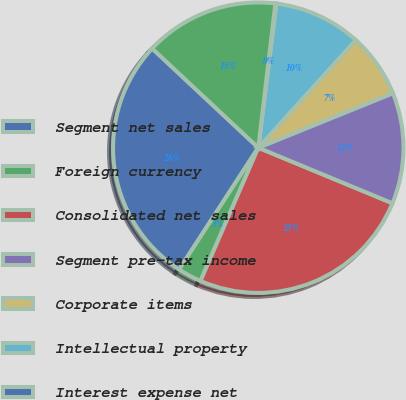Convert chart to OTSL. <chart><loc_0><loc_0><loc_500><loc_500><pie_chart><fcel>Segment net sales<fcel>Foreign currency<fcel>Consolidated net sales<fcel>Segment pre-tax income<fcel>Corporate items<fcel>Intellectual property<fcel>Interest expense net<fcel>Consolidated pre-tax income<nl><fcel>27.8%<fcel>2.66%<fcel>25.26%<fcel>12.37%<fcel>7.17%<fcel>9.71%<fcel>0.12%<fcel>14.91%<nl></chart> 